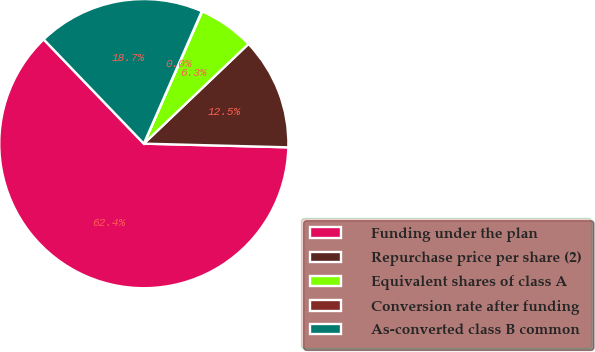Convert chart. <chart><loc_0><loc_0><loc_500><loc_500><pie_chart><fcel>Funding under the plan<fcel>Repurchase price per share (2)<fcel>Equivalent shares of class A<fcel>Conversion rate after funding<fcel>As-converted class B common<nl><fcel>62.42%<fcel>12.52%<fcel>6.28%<fcel>0.04%<fcel>18.75%<nl></chart> 